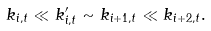Convert formula to latex. <formula><loc_0><loc_0><loc_500><loc_500>k _ { i , t } \ll k ^ { \prime } _ { i , t } \sim k _ { i + 1 , t } \ll k _ { i + 2 , t } .</formula> 